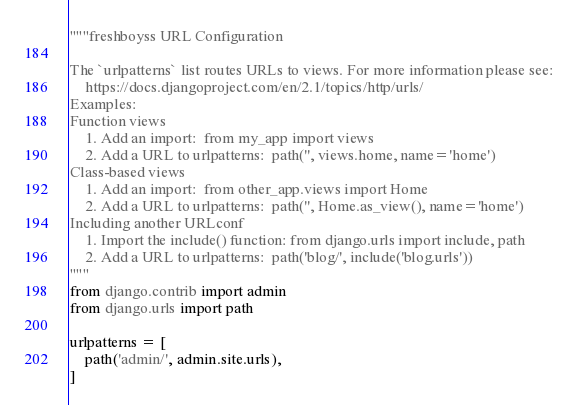<code> <loc_0><loc_0><loc_500><loc_500><_Python_>"""freshboyss URL Configuration

The `urlpatterns` list routes URLs to views. For more information please see:
    https://docs.djangoproject.com/en/2.1/topics/http/urls/
Examples:
Function views
    1. Add an import:  from my_app import views
    2. Add a URL to urlpatterns:  path('', views.home, name='home')
Class-based views
    1. Add an import:  from other_app.views import Home
    2. Add a URL to urlpatterns:  path('', Home.as_view(), name='home')
Including another URLconf
    1. Import the include() function: from django.urls import include, path
    2. Add a URL to urlpatterns:  path('blog/', include('blog.urls'))
"""
from django.contrib import admin
from django.urls import path

urlpatterns = [
    path('admin/', admin.site.urls),
]
</code> 